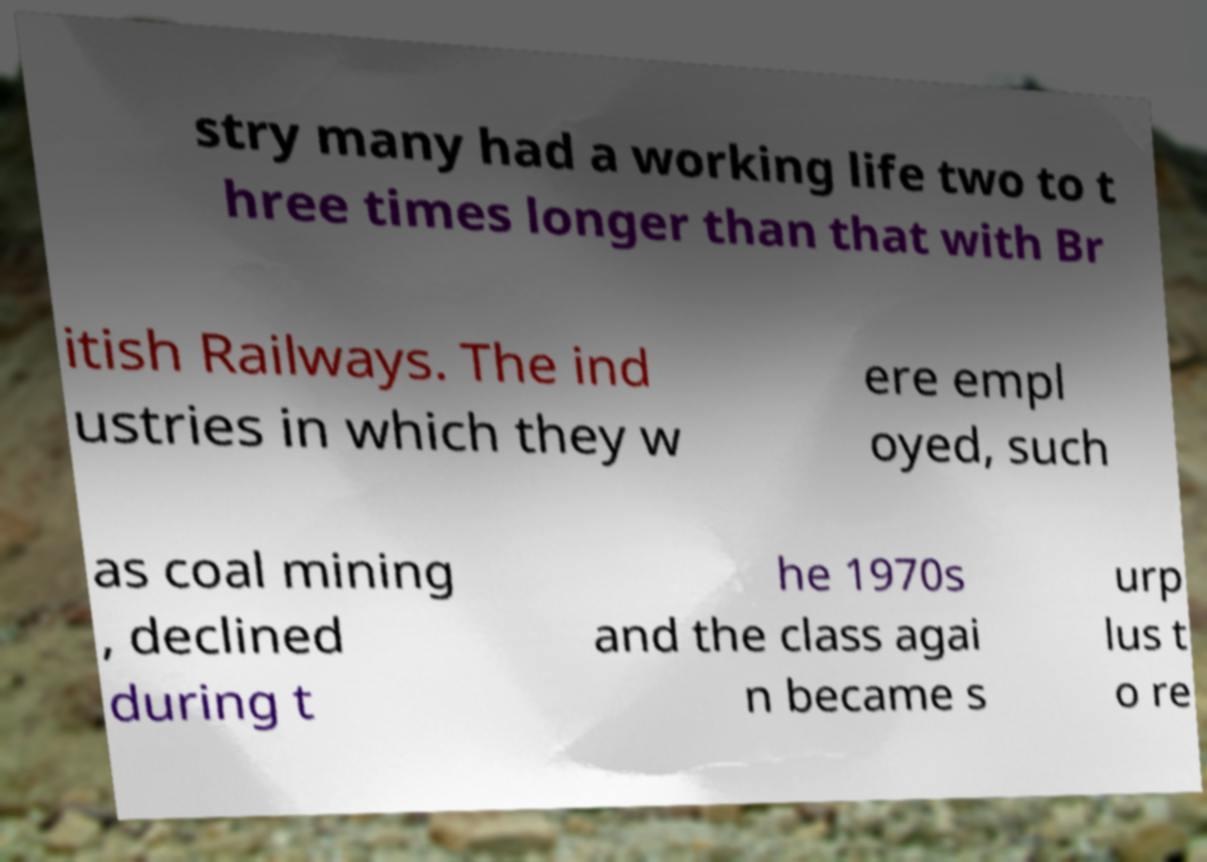Can you read and provide the text displayed in the image?This photo seems to have some interesting text. Can you extract and type it out for me? stry many had a working life two to t hree times longer than that with Br itish Railways. The ind ustries in which they w ere empl oyed, such as coal mining , declined during t he 1970s and the class agai n became s urp lus t o re 